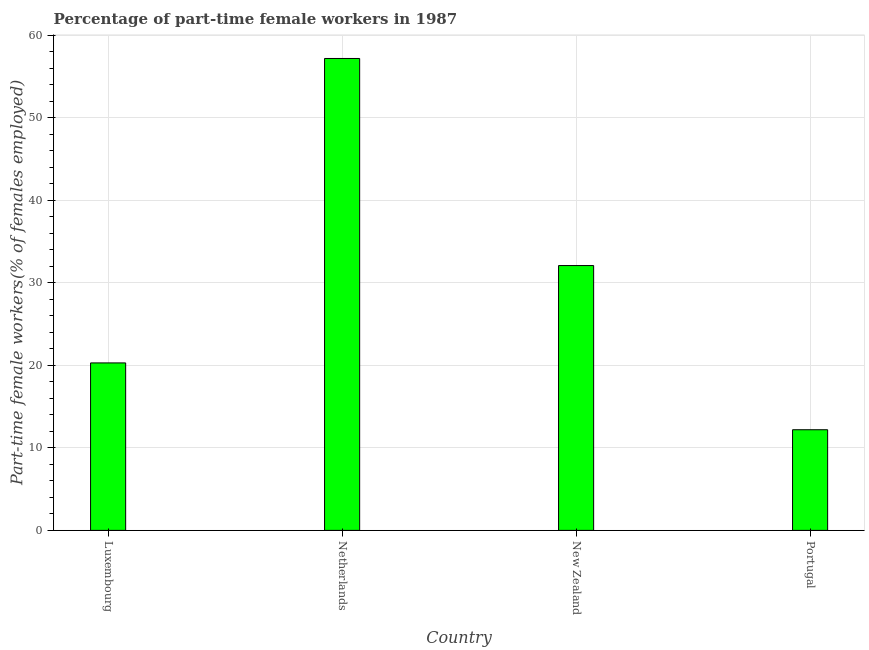Does the graph contain any zero values?
Offer a terse response. No. What is the title of the graph?
Your answer should be very brief. Percentage of part-time female workers in 1987. What is the label or title of the Y-axis?
Make the answer very short. Part-time female workers(% of females employed). What is the percentage of part-time female workers in Netherlands?
Your response must be concise. 57.2. Across all countries, what is the maximum percentage of part-time female workers?
Provide a short and direct response. 57.2. Across all countries, what is the minimum percentage of part-time female workers?
Keep it short and to the point. 12.2. What is the sum of the percentage of part-time female workers?
Offer a terse response. 121.8. What is the difference between the percentage of part-time female workers in Luxembourg and Portugal?
Provide a succinct answer. 8.1. What is the average percentage of part-time female workers per country?
Your response must be concise. 30.45. What is the median percentage of part-time female workers?
Your answer should be very brief. 26.2. In how many countries, is the percentage of part-time female workers greater than 12 %?
Your answer should be very brief. 4. What is the ratio of the percentage of part-time female workers in Netherlands to that in Portugal?
Your answer should be very brief. 4.69. Is the percentage of part-time female workers in Luxembourg less than that in Portugal?
Offer a terse response. No. What is the difference between the highest and the second highest percentage of part-time female workers?
Ensure brevity in your answer.  25.1. How many bars are there?
Provide a short and direct response. 4. What is the difference between two consecutive major ticks on the Y-axis?
Your answer should be very brief. 10. Are the values on the major ticks of Y-axis written in scientific E-notation?
Your answer should be compact. No. What is the Part-time female workers(% of females employed) of Luxembourg?
Keep it short and to the point. 20.3. What is the Part-time female workers(% of females employed) in Netherlands?
Provide a succinct answer. 57.2. What is the Part-time female workers(% of females employed) in New Zealand?
Make the answer very short. 32.1. What is the Part-time female workers(% of females employed) in Portugal?
Make the answer very short. 12.2. What is the difference between the Part-time female workers(% of females employed) in Luxembourg and Netherlands?
Give a very brief answer. -36.9. What is the difference between the Part-time female workers(% of females employed) in Luxembourg and New Zealand?
Provide a succinct answer. -11.8. What is the difference between the Part-time female workers(% of females employed) in Luxembourg and Portugal?
Your answer should be very brief. 8.1. What is the difference between the Part-time female workers(% of females employed) in Netherlands and New Zealand?
Your answer should be compact. 25.1. What is the difference between the Part-time female workers(% of females employed) in Netherlands and Portugal?
Provide a succinct answer. 45. What is the difference between the Part-time female workers(% of females employed) in New Zealand and Portugal?
Offer a very short reply. 19.9. What is the ratio of the Part-time female workers(% of females employed) in Luxembourg to that in Netherlands?
Your answer should be compact. 0.35. What is the ratio of the Part-time female workers(% of females employed) in Luxembourg to that in New Zealand?
Provide a succinct answer. 0.63. What is the ratio of the Part-time female workers(% of females employed) in Luxembourg to that in Portugal?
Keep it short and to the point. 1.66. What is the ratio of the Part-time female workers(% of females employed) in Netherlands to that in New Zealand?
Your answer should be very brief. 1.78. What is the ratio of the Part-time female workers(% of females employed) in Netherlands to that in Portugal?
Offer a very short reply. 4.69. What is the ratio of the Part-time female workers(% of females employed) in New Zealand to that in Portugal?
Keep it short and to the point. 2.63. 